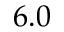Convert formula to latex. <formula><loc_0><loc_0><loc_500><loc_500>6 . 0</formula> 